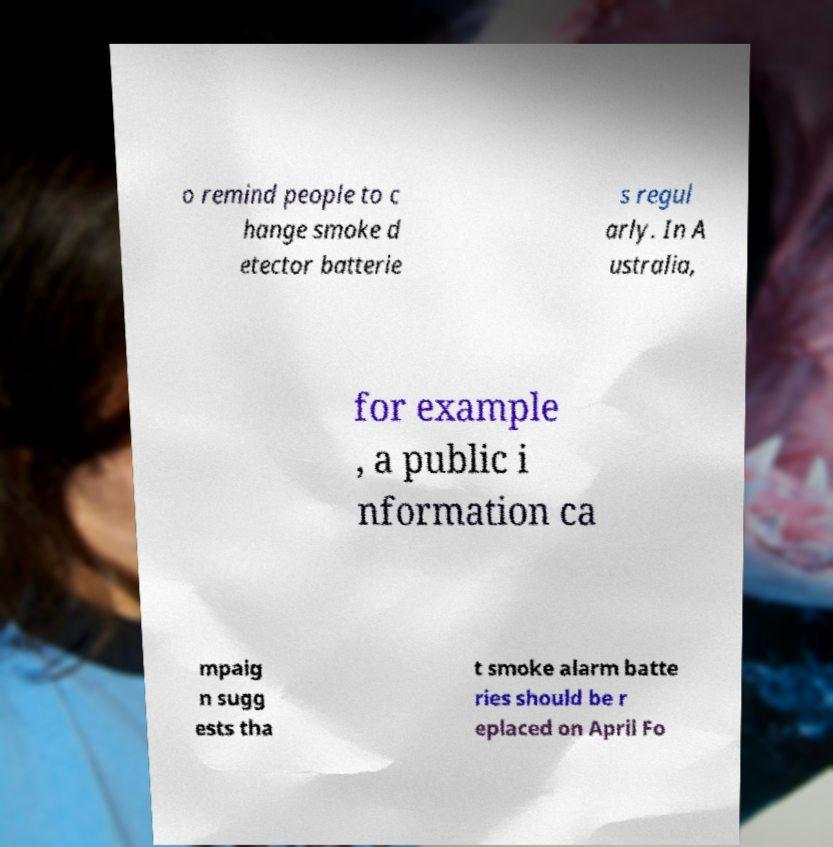Please read and relay the text visible in this image. What does it say? o remind people to c hange smoke d etector batterie s regul arly. In A ustralia, for example , a public i nformation ca mpaig n sugg ests tha t smoke alarm batte ries should be r eplaced on April Fo 